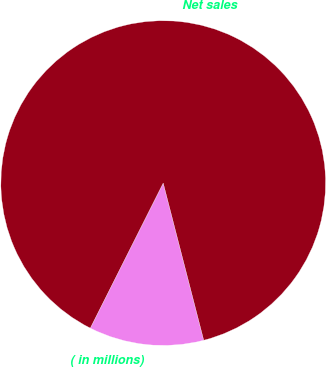<chart> <loc_0><loc_0><loc_500><loc_500><pie_chart><fcel>( in millions)<fcel>Net sales<nl><fcel>11.43%<fcel>88.57%<nl></chart> 